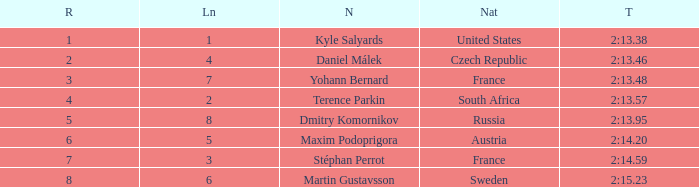What was Stéphan Perrot rank average? 7.0. Give me the full table as a dictionary. {'header': ['R', 'Ln', 'N', 'Nat', 'T'], 'rows': [['1', '1', 'Kyle Salyards', 'United States', '2:13.38'], ['2', '4', 'Daniel Málek', 'Czech Republic', '2:13.46'], ['3', '7', 'Yohann Bernard', 'France', '2:13.48'], ['4', '2', 'Terence Parkin', 'South Africa', '2:13.57'], ['5', '8', 'Dmitry Komornikov', 'Russia', '2:13.95'], ['6', '5', 'Maxim Podoprigora', 'Austria', '2:14.20'], ['7', '3', 'Stéphan Perrot', 'France', '2:14.59'], ['8', '6', 'Martin Gustavsson', 'Sweden', '2:15.23']]} 